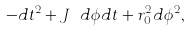<formula> <loc_0><loc_0><loc_500><loc_500>- d t ^ { 2 } + J \ d \phi d t + r _ { 0 } ^ { 2 } d \phi ^ { 2 } ,</formula> 